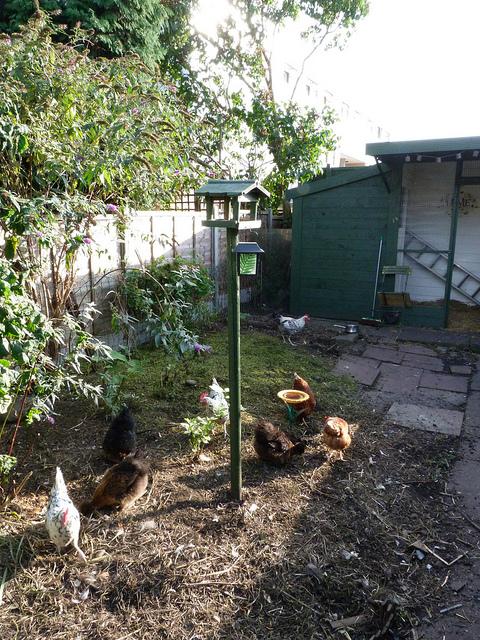How many chickens are there with redheads?
Keep it brief. 1. Who brings the chickens their feed each morning?
Answer briefly. Farmer. What animals are in this picture?
Quick response, please. Chickens. What is that thing leaning against the house in the background?
Keep it brief. Ladder. 